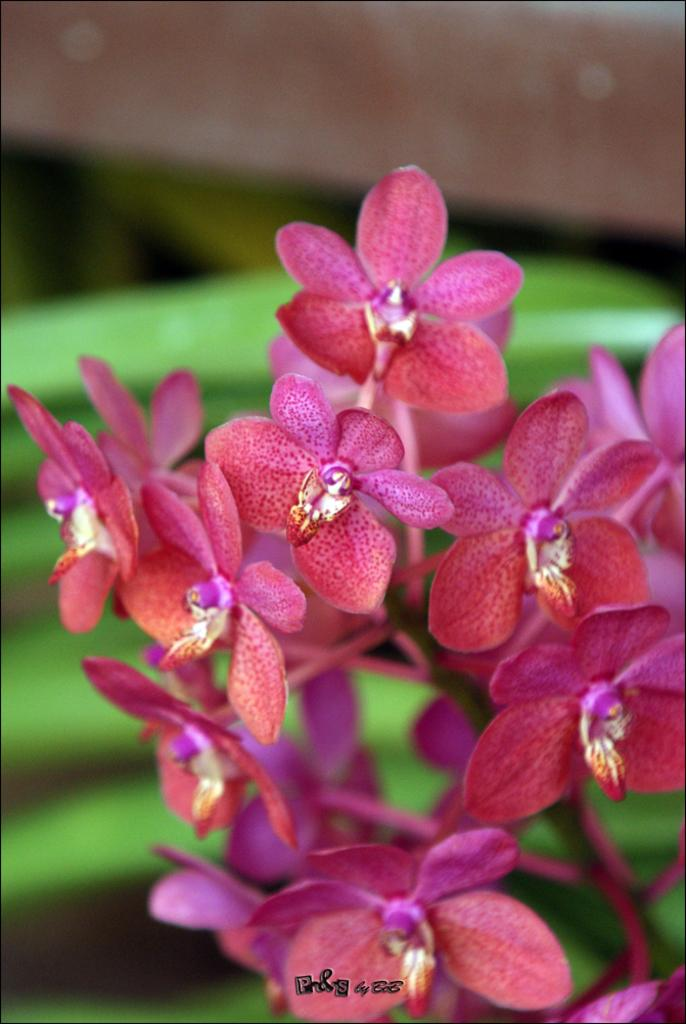What type of plants are in the image? There are flowers in the image. What color are the flowers? The flowers are pink in color. What colors can be seen in the background of the image? The background of the image is green and brown. How is the background of the image depicted? The background is blurred. What type of hose is being used by the fireman in the image? There is no fireman or hose present in the image; it features flowers with a blurred background. 